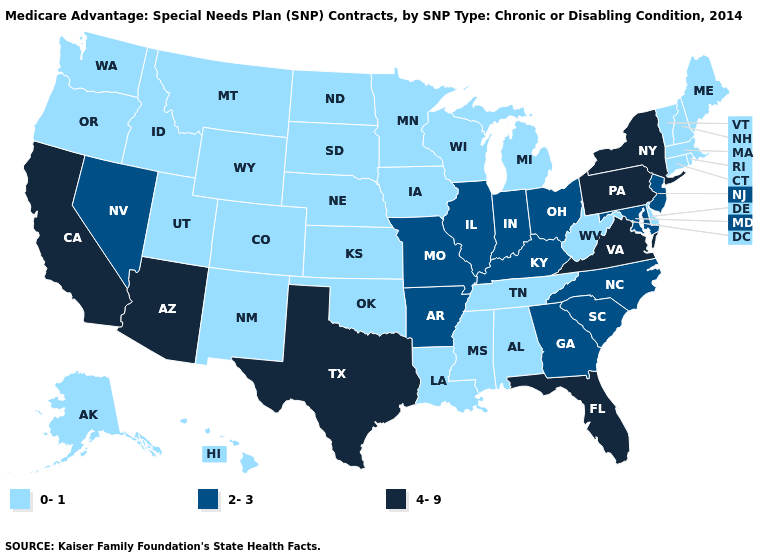Name the states that have a value in the range 0-1?
Write a very short answer. Alaska, Alabama, Colorado, Connecticut, Delaware, Hawaii, Iowa, Idaho, Kansas, Louisiana, Massachusetts, Maine, Michigan, Minnesota, Mississippi, Montana, North Dakota, Nebraska, New Hampshire, New Mexico, Oklahoma, Oregon, Rhode Island, South Dakota, Tennessee, Utah, Vermont, Washington, Wisconsin, West Virginia, Wyoming. Does Vermont have a lower value than Florida?
Short answer required. Yes. Which states hav the highest value in the Northeast?
Write a very short answer. New York, Pennsylvania. What is the value of Alaska?
Quick response, please. 0-1. Name the states that have a value in the range 4-9?
Answer briefly. Arizona, California, Florida, New York, Pennsylvania, Texas, Virginia. Does Alabama have the lowest value in the USA?
Quick response, please. Yes. Does Florida have the lowest value in the USA?
Keep it brief. No. What is the value of South Dakota?
Quick response, please. 0-1. What is the highest value in the South ?
Write a very short answer. 4-9. How many symbols are there in the legend?
Quick response, please. 3. What is the value of Minnesota?
Short answer required. 0-1. Name the states that have a value in the range 2-3?
Write a very short answer. Arkansas, Georgia, Illinois, Indiana, Kentucky, Maryland, Missouri, North Carolina, New Jersey, Nevada, Ohio, South Carolina. Which states have the lowest value in the Northeast?
Answer briefly. Connecticut, Massachusetts, Maine, New Hampshire, Rhode Island, Vermont. What is the lowest value in the USA?
Write a very short answer. 0-1. Does Oregon have a lower value than Idaho?
Answer briefly. No. 